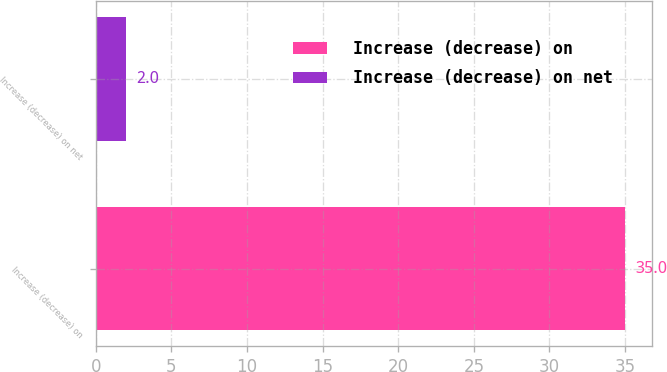Convert chart to OTSL. <chart><loc_0><loc_0><loc_500><loc_500><bar_chart><fcel>Increase (decrease) on<fcel>Increase (decrease) on net<nl><fcel>35<fcel>2<nl></chart> 